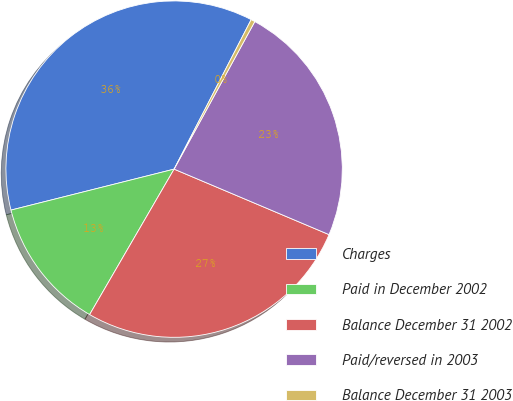Convert chart to OTSL. <chart><loc_0><loc_0><loc_500><loc_500><pie_chart><fcel>Charges<fcel>Paid in December 2002<fcel>Balance December 31 2002<fcel>Paid/reversed in 2003<fcel>Balance December 31 2003<nl><fcel>36.49%<fcel>12.71%<fcel>27.01%<fcel>23.4%<fcel>0.39%<nl></chart> 